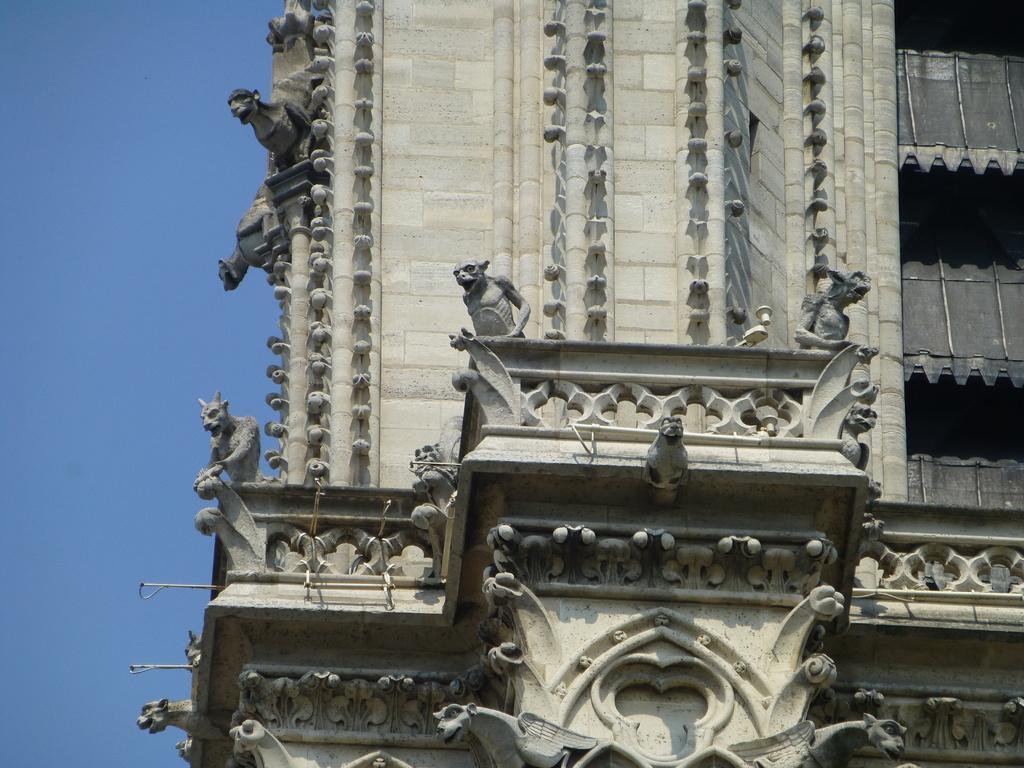Please provide a concise description of this image. In this image there is a building. In the background there is a sky. 